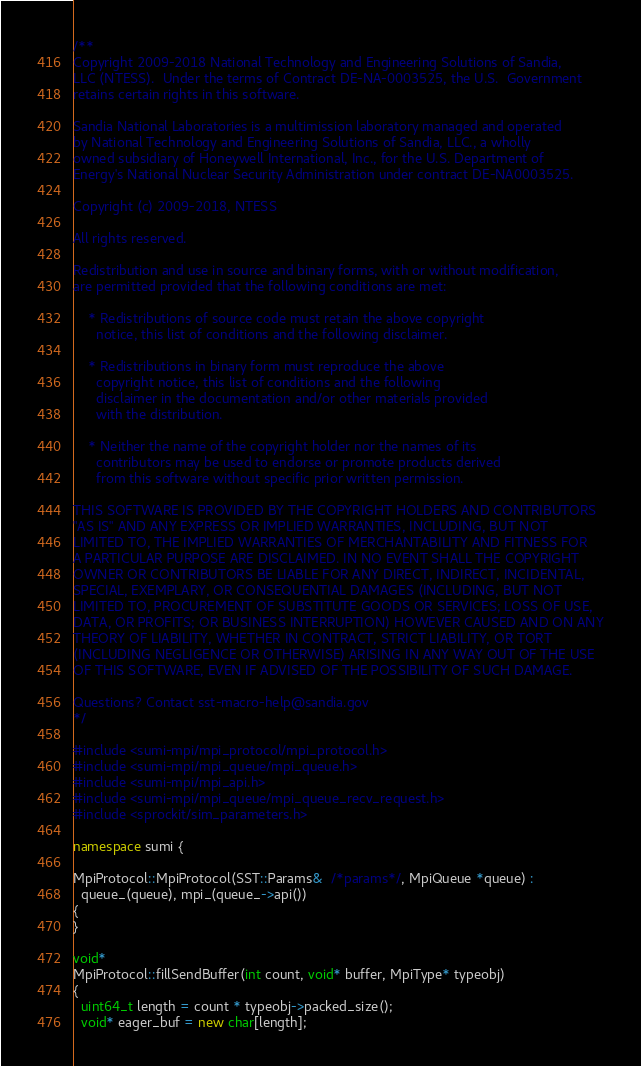Convert code to text. <code><loc_0><loc_0><loc_500><loc_500><_C++_>/**
Copyright 2009-2018 National Technology and Engineering Solutions of Sandia, 
LLC (NTESS).  Under the terms of Contract DE-NA-0003525, the U.S.  Government 
retains certain rights in this software.

Sandia National Laboratories is a multimission laboratory managed and operated
by National Technology and Engineering Solutions of Sandia, LLC., a wholly 
owned subsidiary of Honeywell International, Inc., for the U.S. Department of 
Energy's National Nuclear Security Administration under contract DE-NA0003525.

Copyright (c) 2009-2018, NTESS

All rights reserved.

Redistribution and use in source and binary forms, with or without modification, 
are permitted provided that the following conditions are met:

    * Redistributions of source code must retain the above copyright
      notice, this list of conditions and the following disclaimer.

    * Redistributions in binary form must reproduce the above
      copyright notice, this list of conditions and the following
      disclaimer in the documentation and/or other materials provided
      with the distribution.

    * Neither the name of the copyright holder nor the names of its
      contributors may be used to endorse or promote products derived
      from this software without specific prior written permission.

THIS SOFTWARE IS PROVIDED BY THE COPYRIGHT HOLDERS AND CONTRIBUTORS
"AS IS" AND ANY EXPRESS OR IMPLIED WARRANTIES, INCLUDING, BUT NOT
LIMITED TO, THE IMPLIED WARRANTIES OF MERCHANTABILITY AND FITNESS FOR
A PARTICULAR PURPOSE ARE DISCLAIMED. IN NO EVENT SHALL THE COPYRIGHT
OWNER OR CONTRIBUTORS BE LIABLE FOR ANY DIRECT, INDIRECT, INCIDENTAL,
SPECIAL, EXEMPLARY, OR CONSEQUENTIAL DAMAGES (INCLUDING, BUT NOT
LIMITED TO, PROCUREMENT OF SUBSTITUTE GOODS OR SERVICES; LOSS OF USE,
DATA, OR PROFITS; OR BUSINESS INTERRUPTION) HOWEVER CAUSED AND ON ANY
THEORY OF LIABILITY, WHETHER IN CONTRACT, STRICT LIABILITY, OR TORT
(INCLUDING NEGLIGENCE OR OTHERWISE) ARISING IN ANY WAY OUT OF THE USE
OF THIS SOFTWARE, EVEN IF ADVISED OF THE POSSIBILITY OF SUCH DAMAGE.

Questions? Contact sst-macro-help@sandia.gov
*/

#include <sumi-mpi/mpi_protocol/mpi_protocol.h>
#include <sumi-mpi/mpi_queue/mpi_queue.h>
#include <sumi-mpi/mpi_api.h>
#include <sumi-mpi/mpi_queue/mpi_queue_recv_request.h>
#include <sprockit/sim_parameters.h>

namespace sumi {

MpiProtocol::MpiProtocol(SST::Params&  /*params*/, MpiQueue *queue) :
  queue_(queue), mpi_(queue_->api())
{
}

void*
MpiProtocol::fillSendBuffer(int count, void* buffer, MpiType* typeobj)
{
  uint64_t length = count * typeobj->packed_size();
  void* eager_buf = new char[length];</code> 